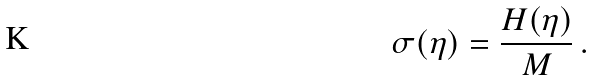<formula> <loc_0><loc_0><loc_500><loc_500>\sigma ( \eta ) = \frac { H ( \eta ) } { M } \, .</formula> 